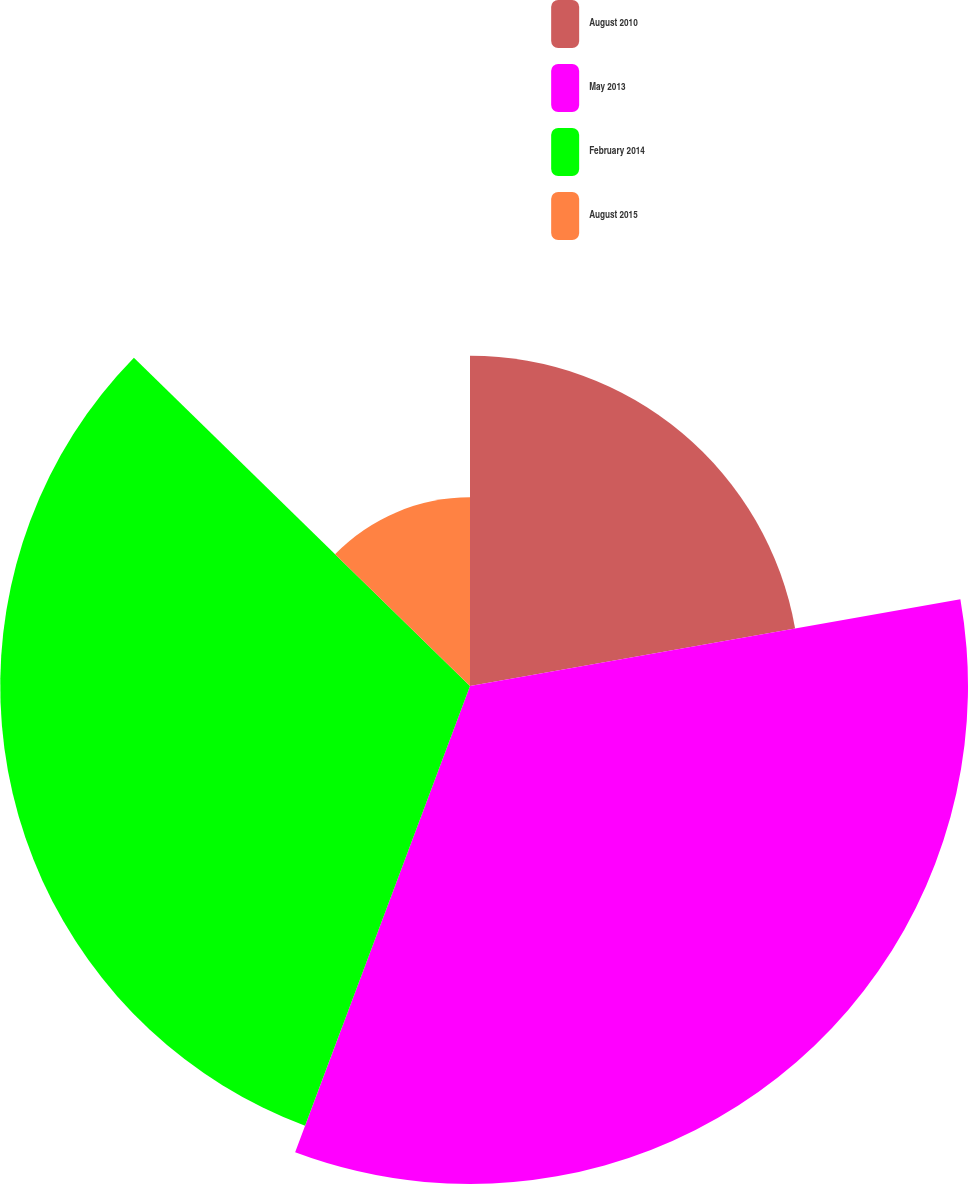Convert chart. <chart><loc_0><loc_0><loc_500><loc_500><pie_chart><fcel>August 2010<fcel>May 2013<fcel>February 2014<fcel>August 2015<nl><fcel>22.21%<fcel>33.5%<fcel>31.6%<fcel>12.69%<nl></chart> 